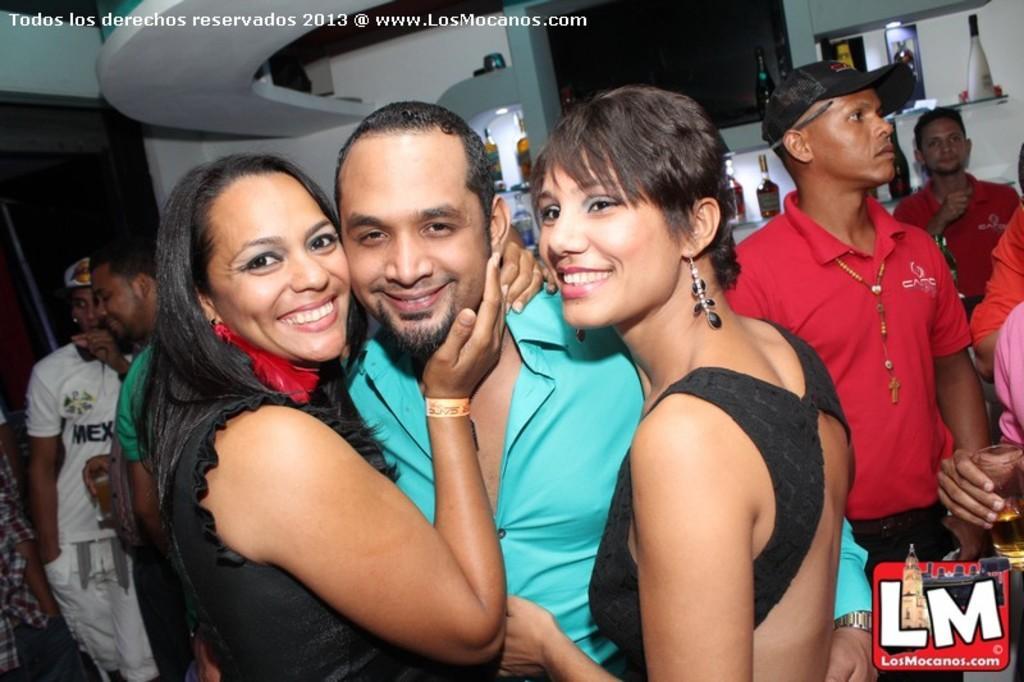Can you describe this image briefly? In the given image i can see a people and behind them i can see lights,bottles,shelves and some other objects. 